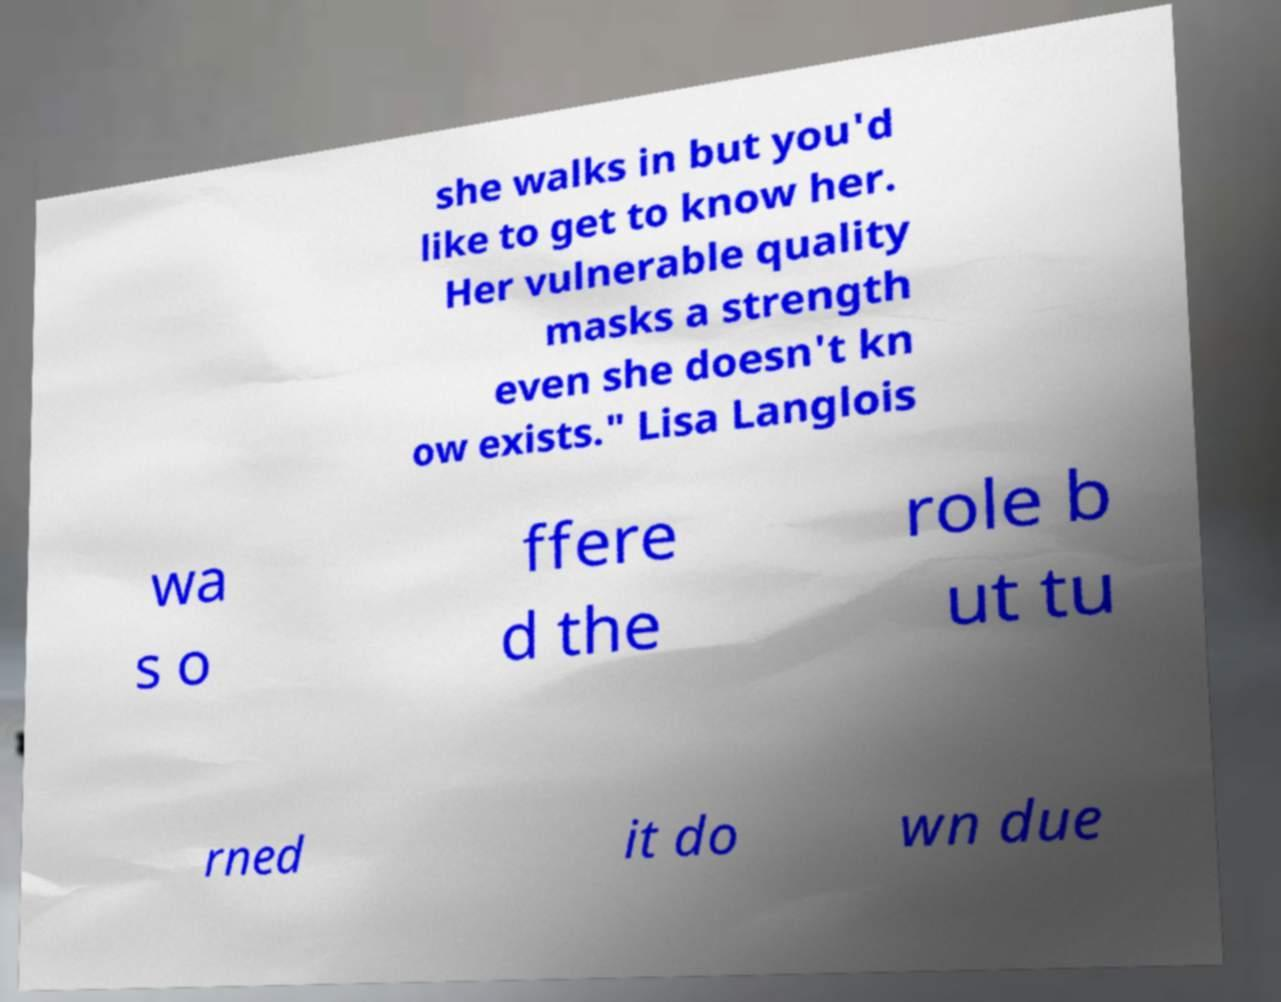For documentation purposes, I need the text within this image transcribed. Could you provide that? she walks in but you'd like to get to know her. Her vulnerable quality masks a strength even she doesn't kn ow exists." Lisa Langlois wa s o ffere d the role b ut tu rned it do wn due 